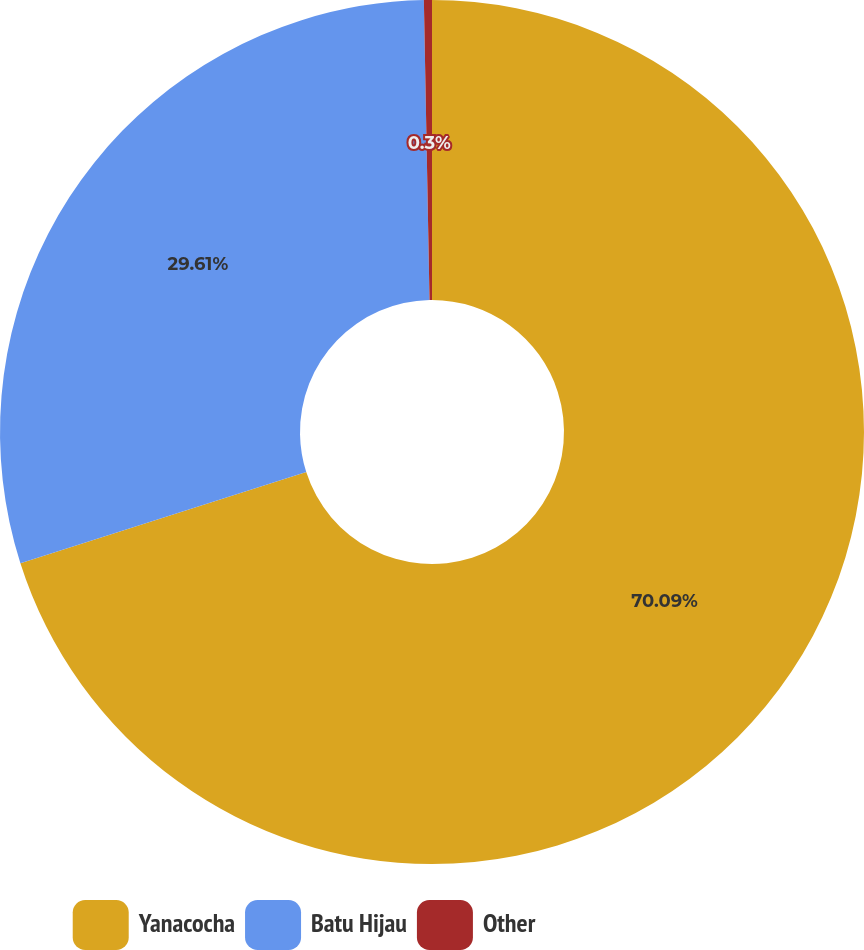<chart> <loc_0><loc_0><loc_500><loc_500><pie_chart><fcel>Yanacocha<fcel>Batu Hijau<fcel>Other<nl><fcel>70.09%<fcel>29.61%<fcel>0.3%<nl></chart> 